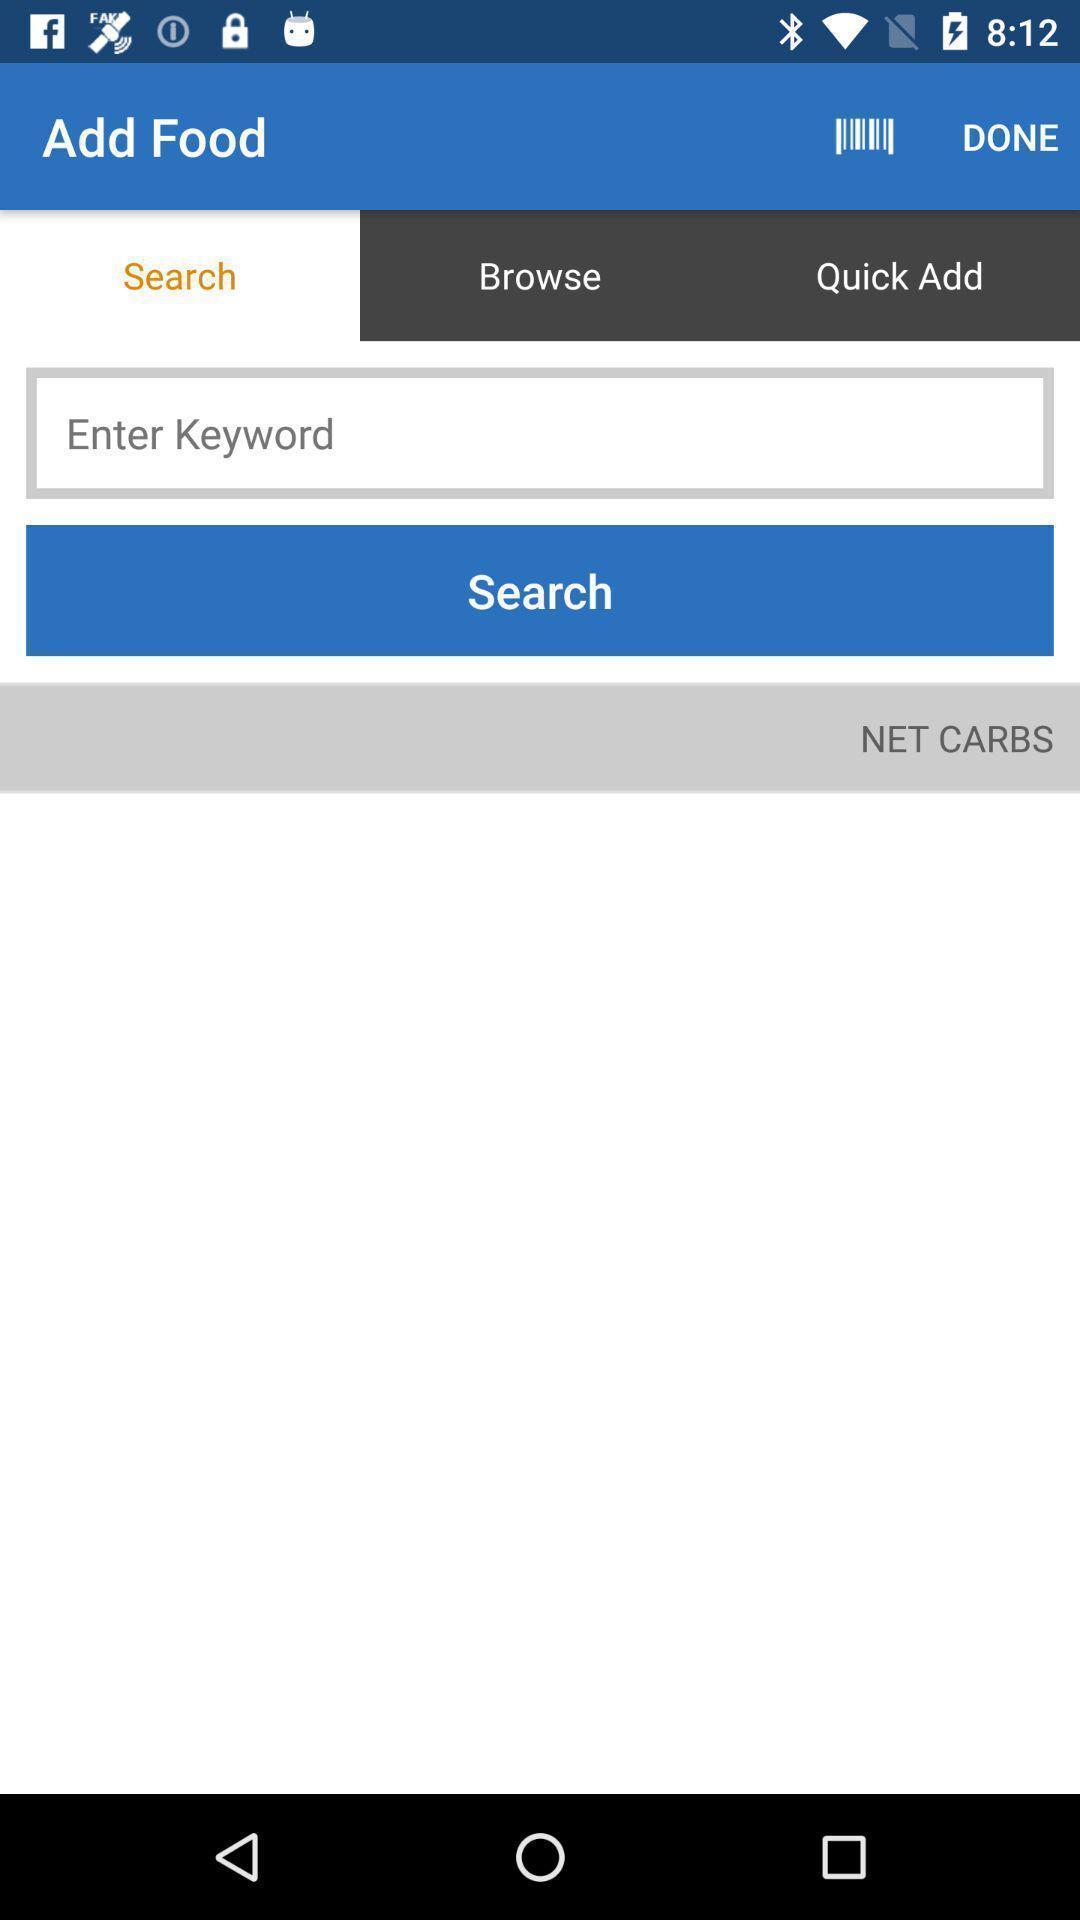Please provide a description for this image. Search page is to find the food in carbs. 